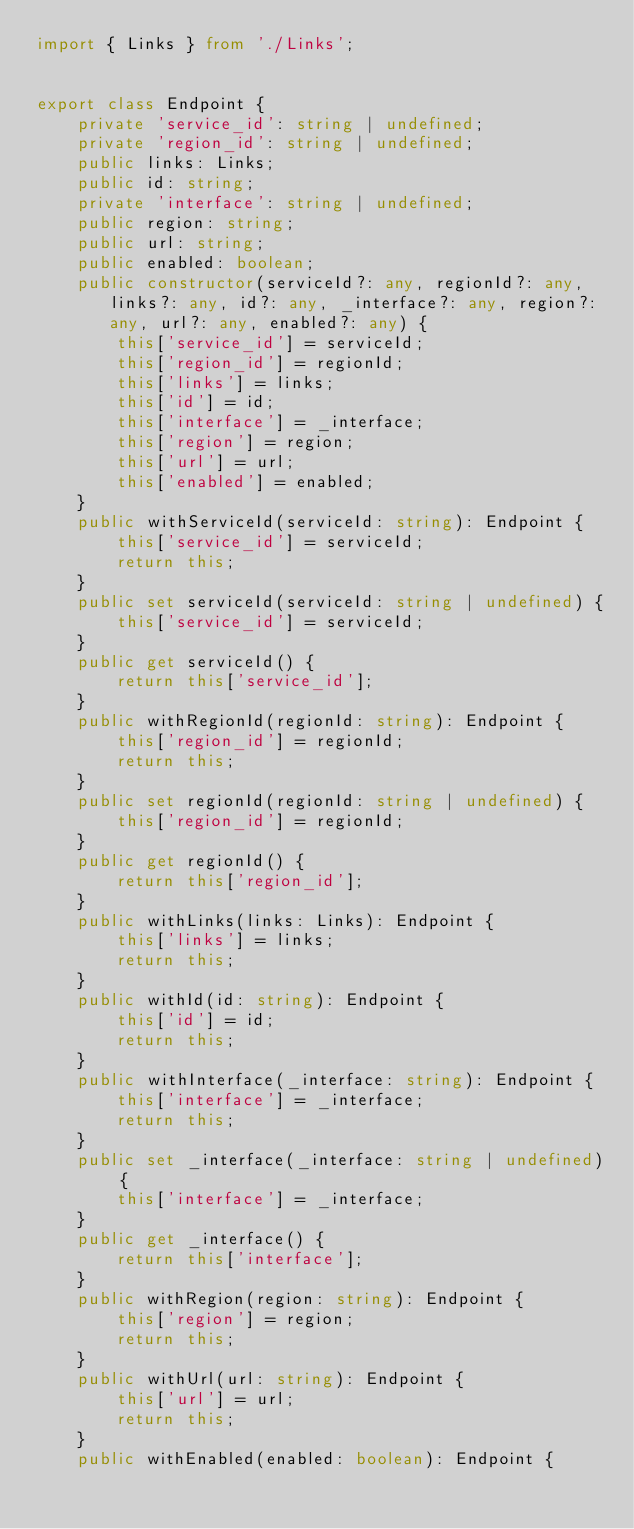Convert code to text. <code><loc_0><loc_0><loc_500><loc_500><_TypeScript_>import { Links } from './Links';


export class Endpoint {
    private 'service_id': string | undefined;
    private 'region_id': string | undefined;
    public links: Links;
    public id: string;
    private 'interface': string | undefined;
    public region: string;
    public url: string;
    public enabled: boolean;
    public constructor(serviceId?: any, regionId?: any, links?: any, id?: any, _interface?: any, region?: any, url?: any, enabled?: any) { 
        this['service_id'] = serviceId;
        this['region_id'] = regionId;
        this['links'] = links;
        this['id'] = id;
        this['interface'] = _interface;
        this['region'] = region;
        this['url'] = url;
        this['enabled'] = enabled;
    }
    public withServiceId(serviceId: string): Endpoint {
        this['service_id'] = serviceId;
        return this;
    }
    public set serviceId(serviceId: string | undefined) {
        this['service_id'] = serviceId;
    }
    public get serviceId() {
        return this['service_id'];
    }
    public withRegionId(regionId: string): Endpoint {
        this['region_id'] = regionId;
        return this;
    }
    public set regionId(regionId: string | undefined) {
        this['region_id'] = regionId;
    }
    public get regionId() {
        return this['region_id'];
    }
    public withLinks(links: Links): Endpoint {
        this['links'] = links;
        return this;
    }
    public withId(id: string): Endpoint {
        this['id'] = id;
        return this;
    }
    public withInterface(_interface: string): Endpoint {
        this['interface'] = _interface;
        return this;
    }
    public set _interface(_interface: string | undefined) {
        this['interface'] = _interface;
    }
    public get _interface() {
        return this['interface'];
    }
    public withRegion(region: string): Endpoint {
        this['region'] = region;
        return this;
    }
    public withUrl(url: string): Endpoint {
        this['url'] = url;
        return this;
    }
    public withEnabled(enabled: boolean): Endpoint {</code> 